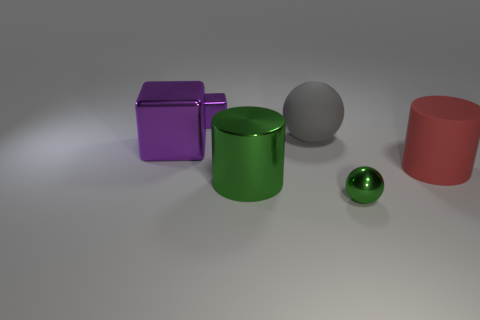What might be the purpose of arranging these objects in this way? This arrangement of objects could be intended to showcase different geometric forms and their textures, possibly for an artistic composition or a study in three-dimensional rendering. Could these objects have practical functions in real life? Yes, in a practical context, these objects could represent containers, like the green cylinder resembling a jar, and the purple cube could be a box, while the spheres might be ball bearings or decorative objects. 